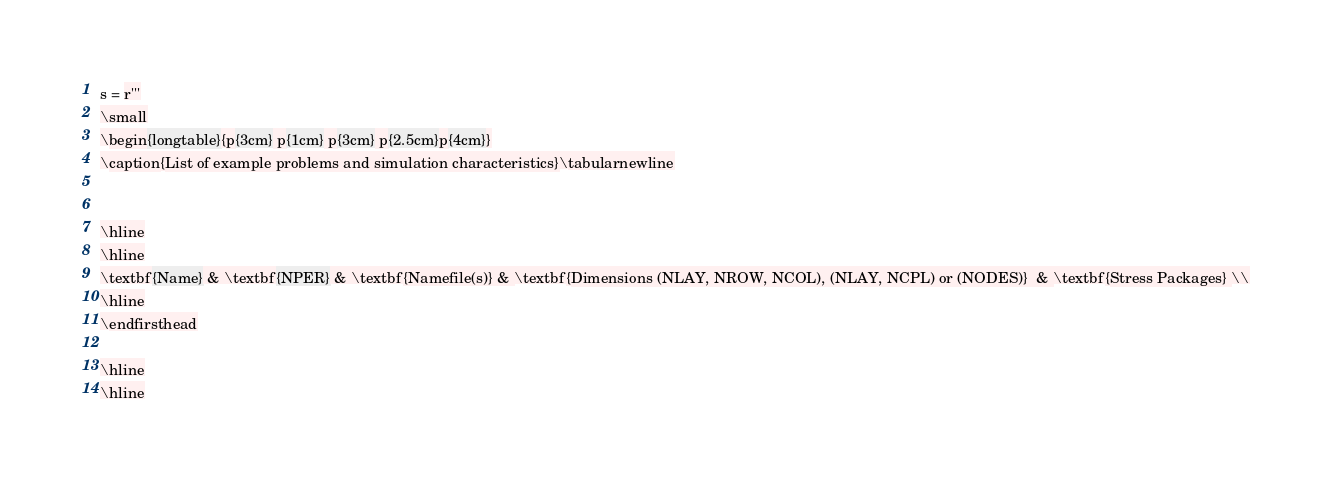Convert code to text. <code><loc_0><loc_0><loc_500><loc_500><_Python_>
s = r'''
\small
\begin{longtable}{p{3cm} p{1cm} p{3cm} p{2.5cm}p{4cm}}
\caption{List of example problems and simulation characteristics}\tabularnewline


\hline
\hline
\textbf{Name} & \textbf{NPER} & \textbf{Namefile(s)} & \textbf{Dimensions (NLAY, NROW, NCOL), (NLAY, NCPL) or (NODES)}  & \textbf{Stress Packages} \\
\hline
\endfirsthead

\hline
\hline</code> 